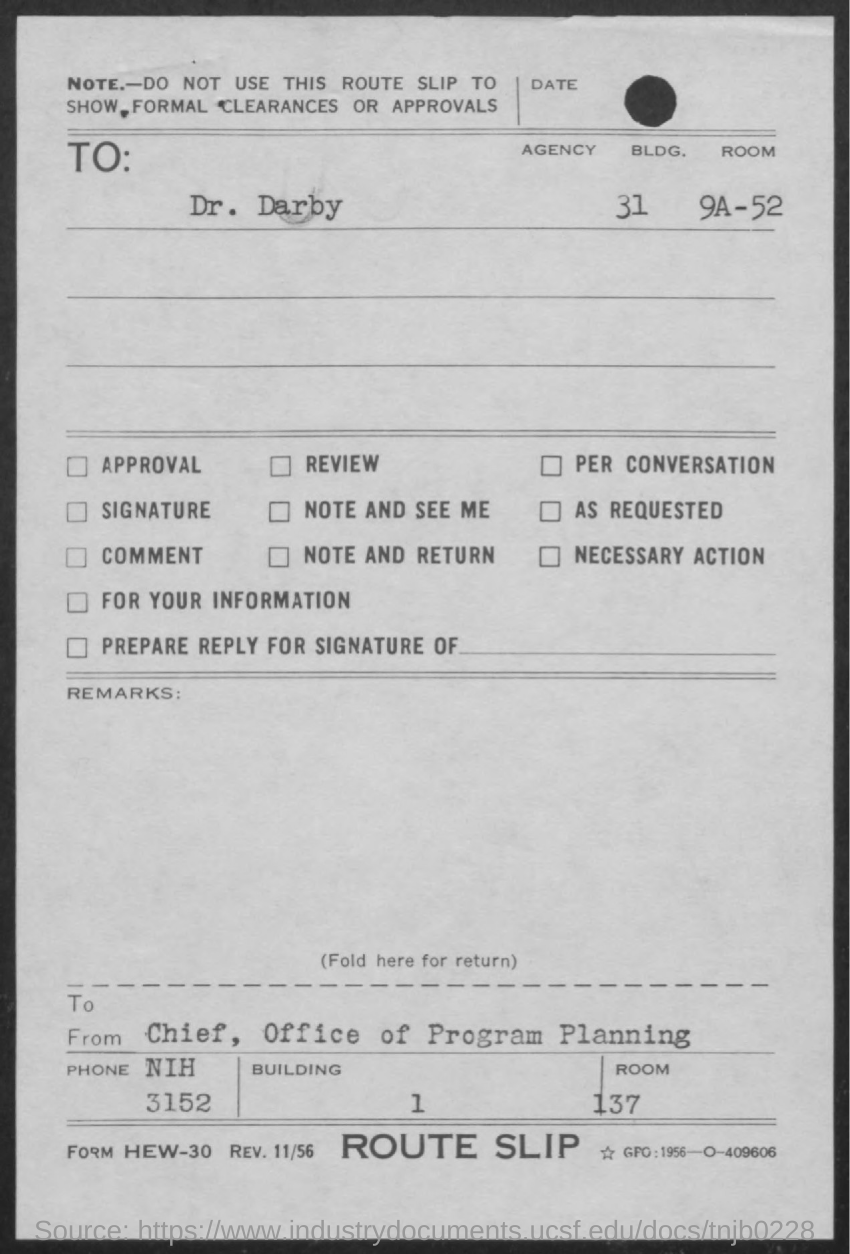Indicate a few pertinent items in this graphic. The letter is addressed to Dr. Darby. This letter is from the Chief of the Office of Program Planning. 